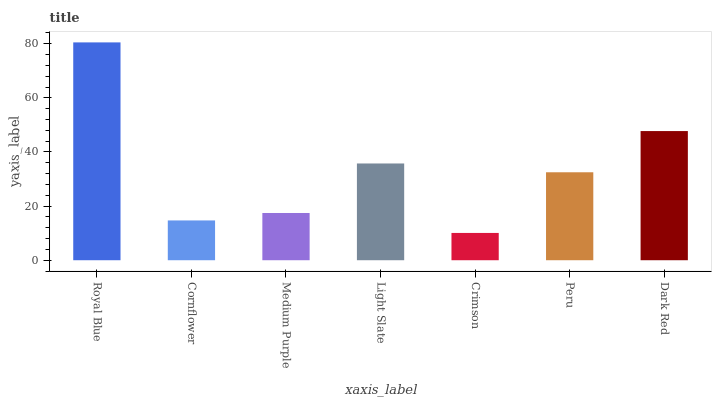Is Crimson the minimum?
Answer yes or no. Yes. Is Royal Blue the maximum?
Answer yes or no. Yes. Is Cornflower the minimum?
Answer yes or no. No. Is Cornflower the maximum?
Answer yes or no. No. Is Royal Blue greater than Cornflower?
Answer yes or no. Yes. Is Cornflower less than Royal Blue?
Answer yes or no. Yes. Is Cornflower greater than Royal Blue?
Answer yes or no. No. Is Royal Blue less than Cornflower?
Answer yes or no. No. Is Peru the high median?
Answer yes or no. Yes. Is Peru the low median?
Answer yes or no. Yes. Is Royal Blue the high median?
Answer yes or no. No. Is Crimson the low median?
Answer yes or no. No. 